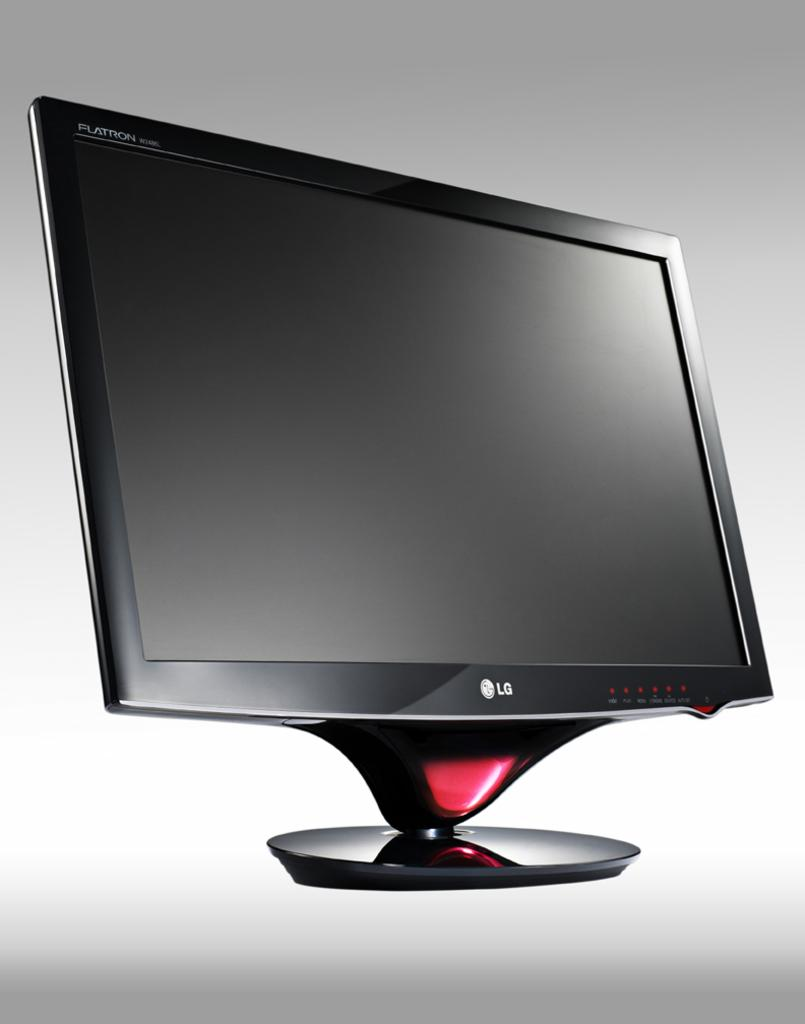<image>
Offer a succinct explanation of the picture presented. The computer screen shown is made by LG. 